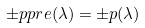<formula> <loc_0><loc_0><loc_500><loc_500>\pm p p r e ( \lambda ) & = \pm p ( \lambda )</formula> 